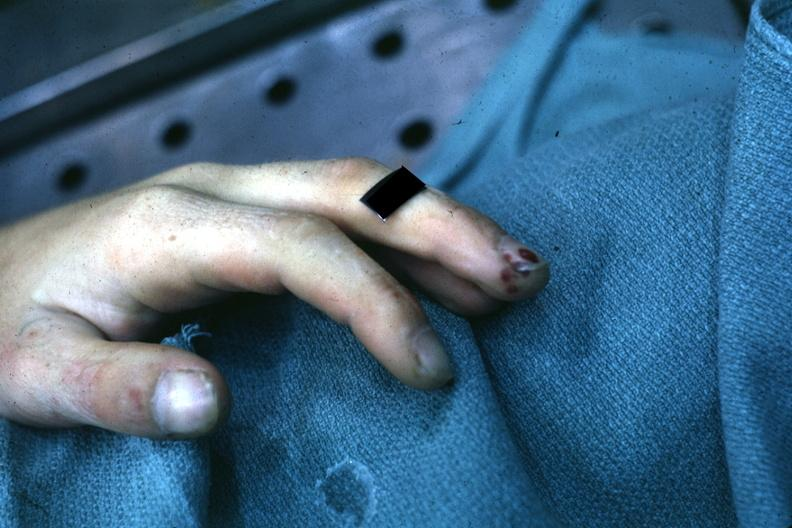s gangrene present?
Answer the question using a single word or phrase. Yes 